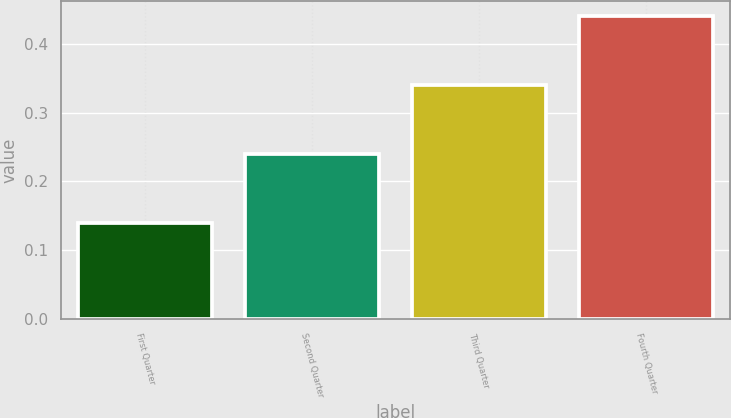Convert chart. <chart><loc_0><loc_0><loc_500><loc_500><bar_chart><fcel>First Quarter<fcel>Second Quarter<fcel>Third Quarter<fcel>Fourth Quarter<nl><fcel>0.14<fcel>0.24<fcel>0.34<fcel>0.44<nl></chart> 